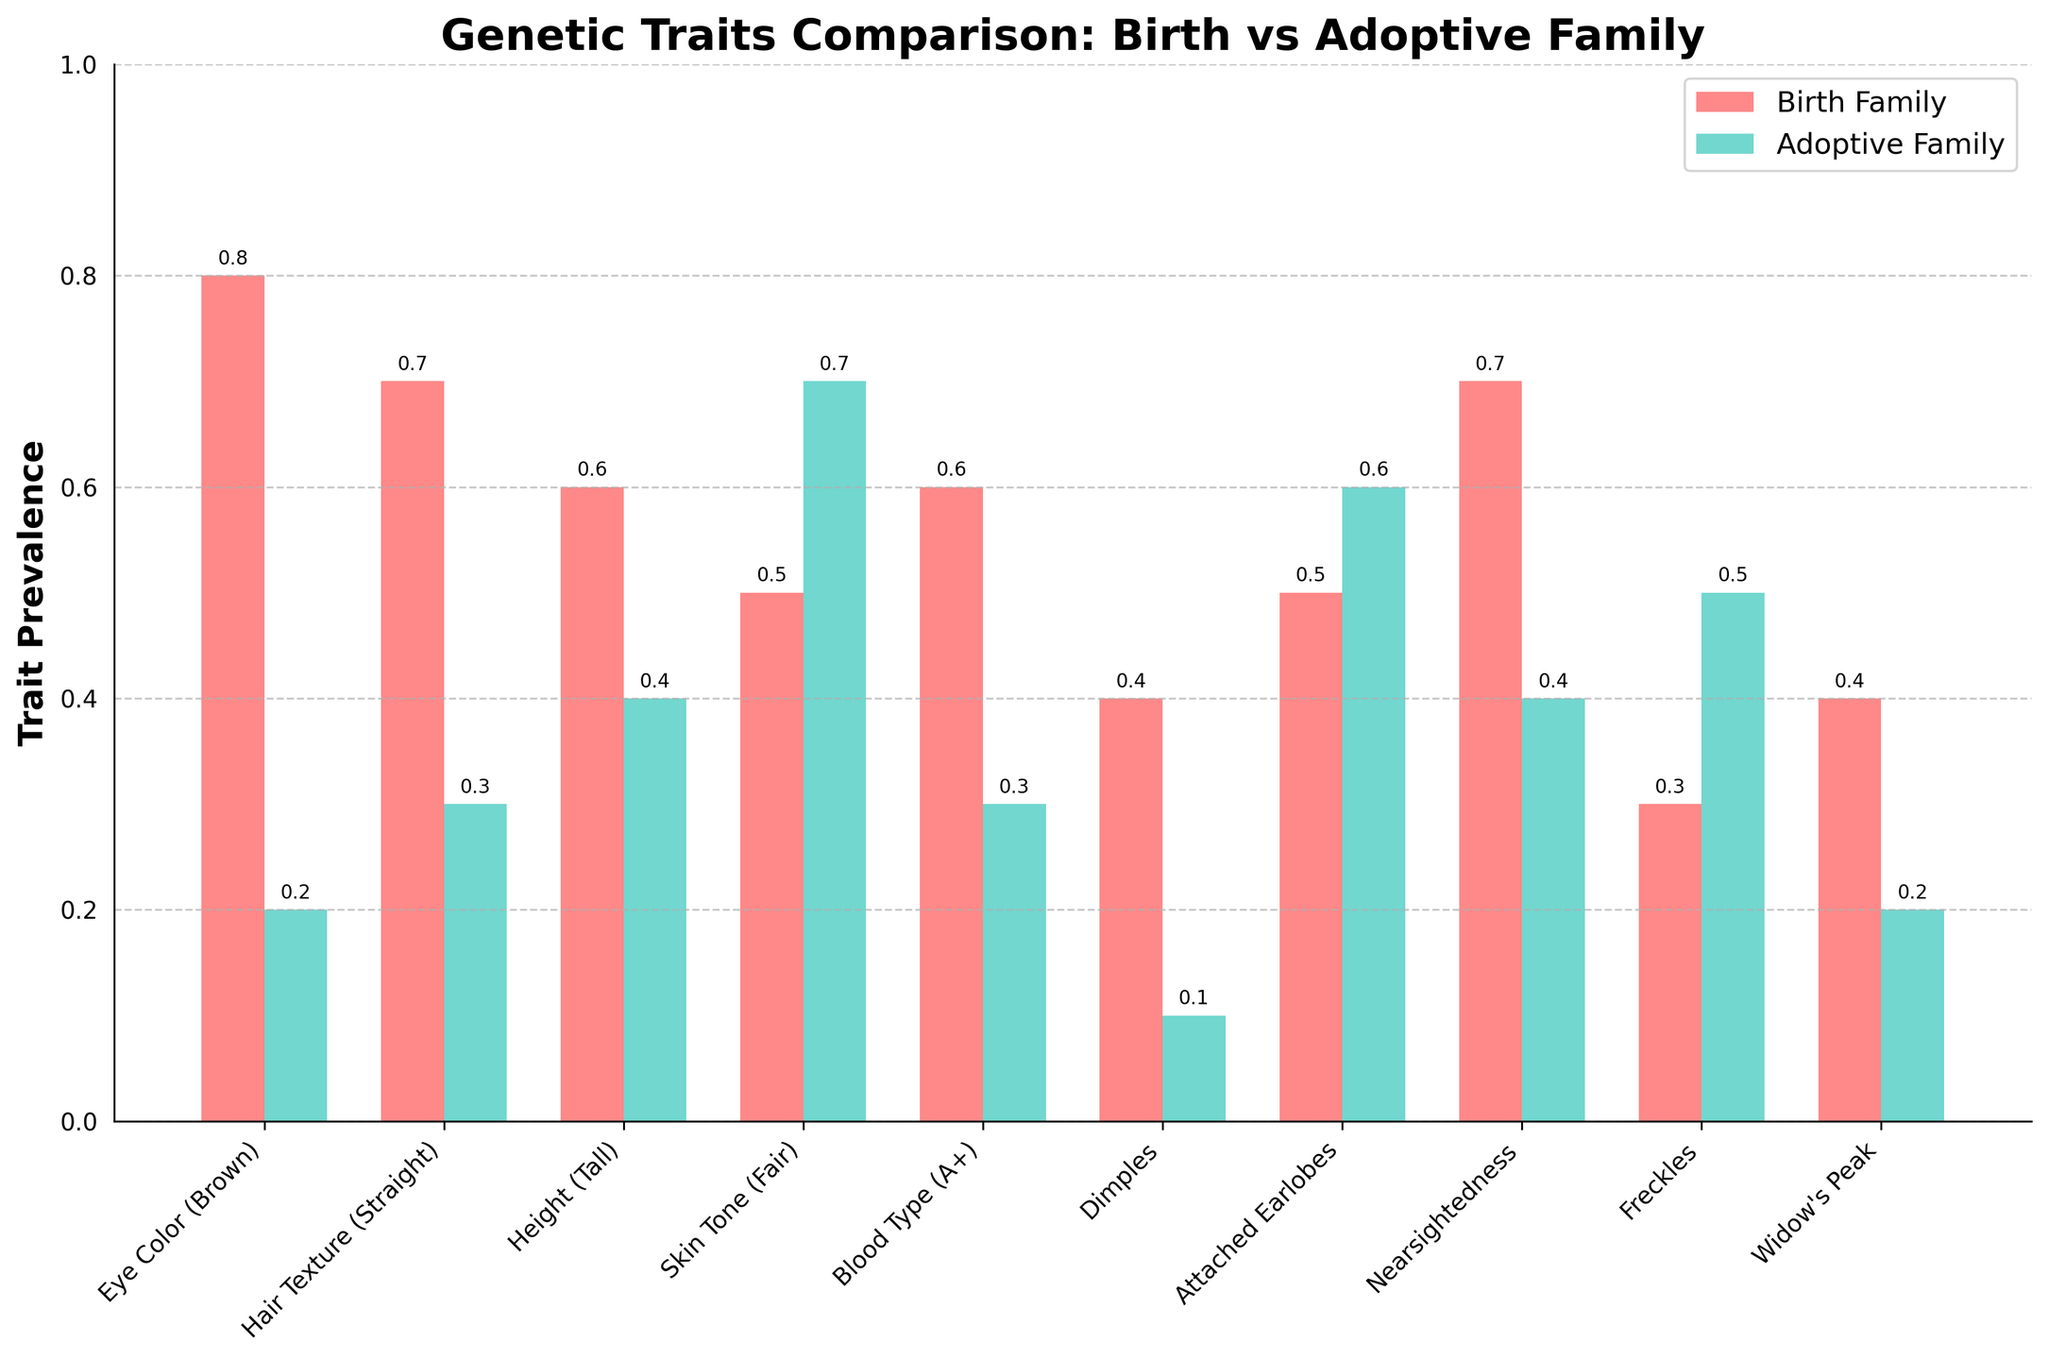How many traits are compared in the figure? The x-axis lists distinct traits being compared. Count these traits to find the answer.
Answer: 10 What is the title of the figure? The title is displayed at the top of the figure.
Answer: Genetic Traits Comparison: Birth vs Adoptive Family Which family shows a higher prevalence of fair skin tone? Compare the heights of the bars for the skin tone trait between both families.
Answer: Adoptive Family What is the difference in the prevalence of brown eye color between birth and adoptive families? Look at the height values for brown eye color in both families and subtract the smaller value from the larger one. Birth Family shows 0.8 and Adoptive Family shows 0.2, so 0.8 - 0.2 = 0.6
Answer: 0.6 Between which two traits is there the largest difference in prevalence within the birth family? Compare all adjacent trait values within the birth family, and identify the pair with the maximum difference. Dimples to Freckles shows the largest within-family difference (0.4 to 0.3).
Answer: Dimples and Freckles Which trait is equally prevalent in both families? Scan through the bar heights for each trait and identify if any of them match exactly. Attached Earlobes show equal prevalence in both families (0.5 each).
Answer: Attached Earlobes For how many traits is the adoptive family more prevalent than the birth family? Compare the bar heights for each trait and count the instances where the adoptive family exceeds the birth family. This happens for Skin Tone, Attached Earlobes, and Freckles, making it 3 traits.
Answer: 3 traits What trait has the closest prevalence between both families, other than those with equal prevalence? Calculate the absolute difference in prevalence between both families for each trait and find the minimum non-zero value. For Widow's Peak, the difference is 0.4 - 0.2 = 0.2.
Answer: Widow's Peak Which traits have a greater than 0.3 prevalence difference in the birth family compared to the adoptive family? Calculate the absolute difference for each trait and identify if any differences are greater than 0.3. Brown Eye Color (0.6) and Dimples (0.3) fit this criteria.
Answer: Eye Color (Brown), Dimples 